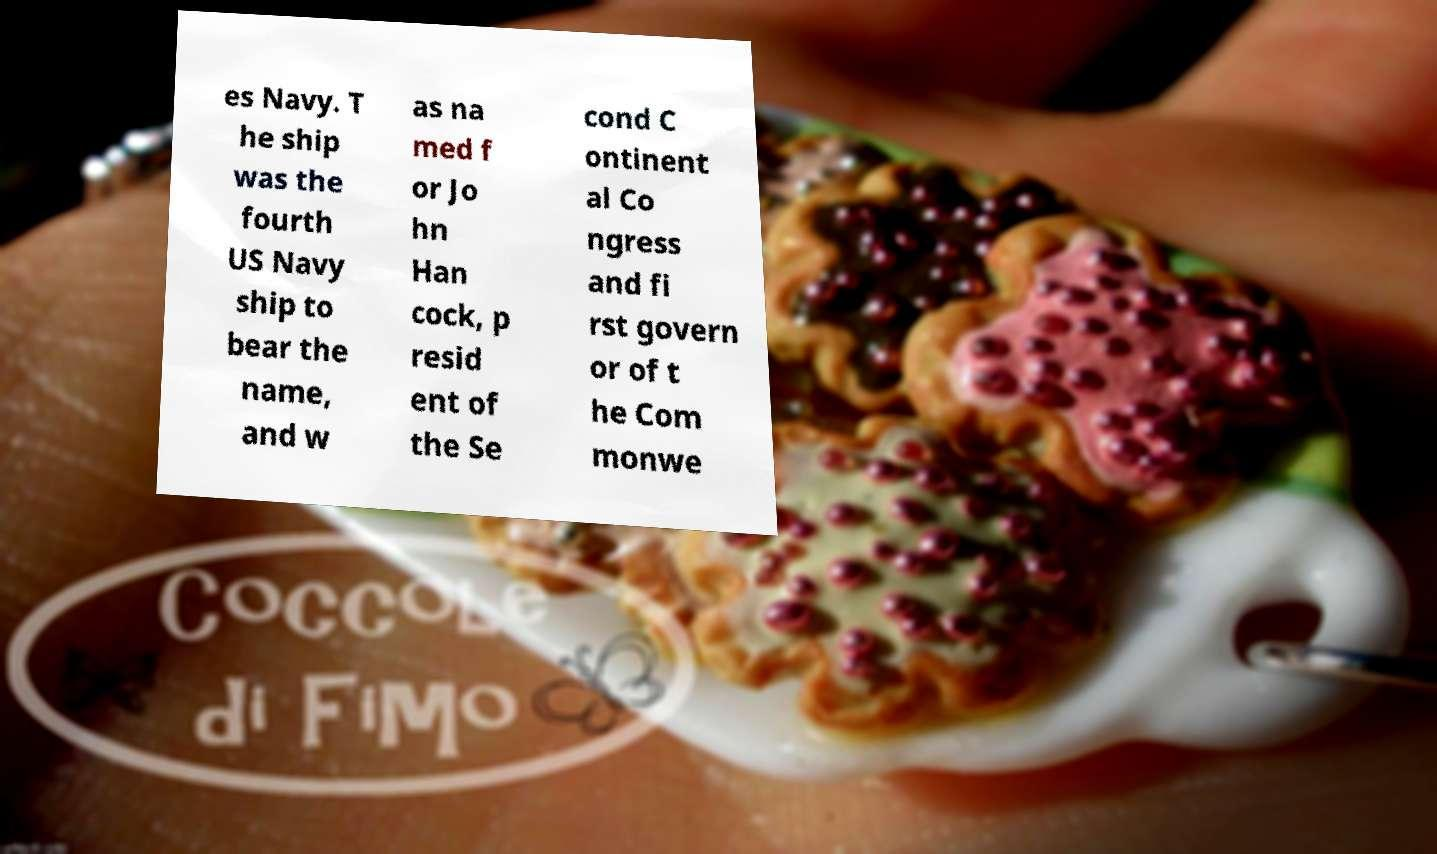For documentation purposes, I need the text within this image transcribed. Could you provide that? es Navy. T he ship was the fourth US Navy ship to bear the name, and w as na med f or Jo hn Han cock, p resid ent of the Se cond C ontinent al Co ngress and fi rst govern or of t he Com monwe 